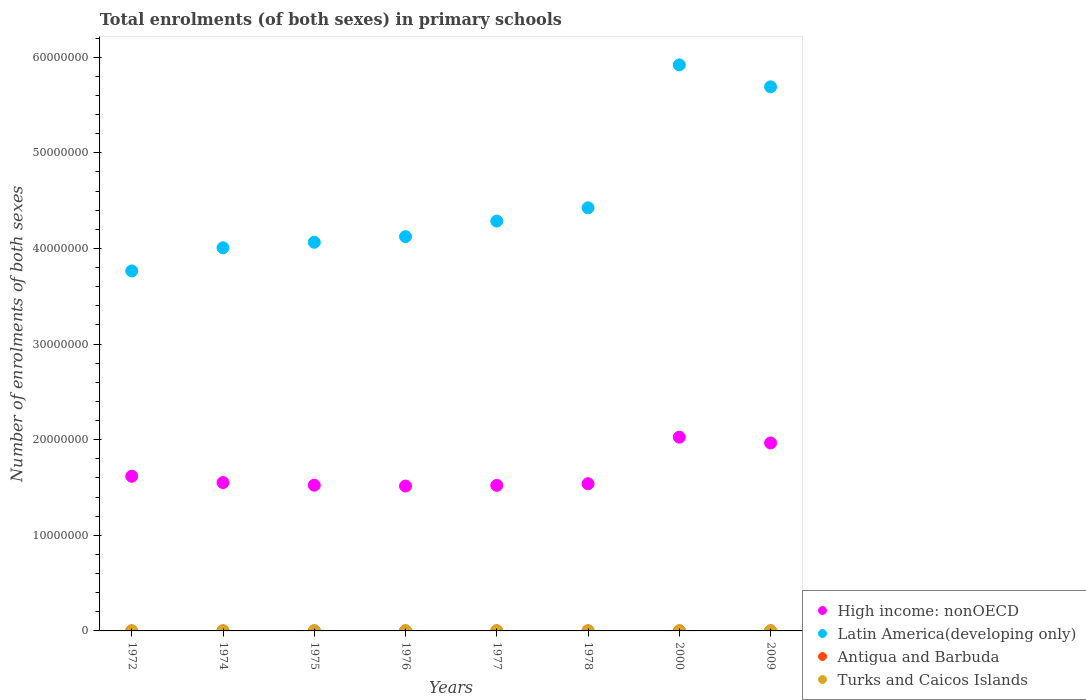How many different coloured dotlines are there?
Ensure brevity in your answer.  4. What is the number of enrolments in primary schools in High income: nonOECD in 1978?
Your answer should be compact. 1.54e+07. Across all years, what is the maximum number of enrolments in primary schools in Latin America(developing only)?
Offer a very short reply. 5.92e+07. Across all years, what is the minimum number of enrolments in primary schools in Turks and Caicos Islands?
Offer a terse response. 1626. In which year was the number of enrolments in primary schools in Turks and Caicos Islands minimum?
Keep it short and to the point. 1975. What is the total number of enrolments in primary schools in Turks and Caicos Islands in the graph?
Give a very brief answer. 1.52e+04. What is the difference between the number of enrolments in primary schools in Antigua and Barbuda in 2000 and that in 2009?
Give a very brief answer. 1749. What is the difference between the number of enrolments in primary schools in Turks and Caicos Islands in 1975 and the number of enrolments in primary schools in High income: nonOECD in 1974?
Your answer should be very brief. -1.55e+07. What is the average number of enrolments in primary schools in Turks and Caicos Islands per year?
Provide a short and direct response. 1906.25. In the year 2000, what is the difference between the number of enrolments in primary schools in Antigua and Barbuda and number of enrolments in primary schools in High income: nonOECD?
Make the answer very short. -2.03e+07. What is the ratio of the number of enrolments in primary schools in Turks and Caicos Islands in 1976 to that in 2009?
Provide a succinct answer. 0.61. Is the number of enrolments in primary schools in Antigua and Barbuda in 1976 less than that in 1978?
Ensure brevity in your answer.  No. Is the difference between the number of enrolments in primary schools in Antigua and Barbuda in 1972 and 1974 greater than the difference between the number of enrolments in primary schools in High income: nonOECD in 1972 and 1974?
Provide a succinct answer. No. What is the difference between the highest and the second highest number of enrolments in primary schools in Latin America(developing only)?
Make the answer very short. 2.30e+06. What is the difference between the highest and the lowest number of enrolments in primary schools in High income: nonOECD?
Your answer should be compact. 5.11e+06. In how many years, is the number of enrolments in primary schools in Latin America(developing only) greater than the average number of enrolments in primary schools in Latin America(developing only) taken over all years?
Ensure brevity in your answer.  2. Is it the case that in every year, the sum of the number of enrolments in primary schools in Antigua and Barbuda and number of enrolments in primary schools in Turks and Caicos Islands  is greater than the sum of number of enrolments in primary schools in High income: nonOECD and number of enrolments in primary schools in Latin America(developing only)?
Give a very brief answer. No. Does the number of enrolments in primary schools in Turks and Caicos Islands monotonically increase over the years?
Offer a very short reply. No. Is the number of enrolments in primary schools in Latin America(developing only) strictly greater than the number of enrolments in primary schools in High income: nonOECD over the years?
Your answer should be very brief. Yes. Is the number of enrolments in primary schools in Latin America(developing only) strictly less than the number of enrolments in primary schools in Turks and Caicos Islands over the years?
Make the answer very short. No. How many years are there in the graph?
Your response must be concise. 8. Are the values on the major ticks of Y-axis written in scientific E-notation?
Provide a short and direct response. No. Does the graph contain any zero values?
Make the answer very short. No. Does the graph contain grids?
Provide a succinct answer. No. How many legend labels are there?
Your answer should be compact. 4. What is the title of the graph?
Give a very brief answer. Total enrolments (of both sexes) in primary schools. Does "Tuvalu" appear as one of the legend labels in the graph?
Offer a terse response. No. What is the label or title of the X-axis?
Your answer should be compact. Years. What is the label or title of the Y-axis?
Offer a terse response. Number of enrolments of both sexes. What is the Number of enrolments of both sexes in High income: nonOECD in 1972?
Offer a terse response. 1.62e+07. What is the Number of enrolments of both sexes in Latin America(developing only) in 1972?
Your answer should be very brief. 3.76e+07. What is the Number of enrolments of both sexes in Antigua and Barbuda in 1972?
Ensure brevity in your answer.  1.19e+04. What is the Number of enrolments of both sexes of Turks and Caicos Islands in 1972?
Ensure brevity in your answer.  1791. What is the Number of enrolments of both sexes of High income: nonOECD in 1974?
Give a very brief answer. 1.55e+07. What is the Number of enrolments of both sexes in Latin America(developing only) in 1974?
Keep it short and to the point. 4.01e+07. What is the Number of enrolments of both sexes of Antigua and Barbuda in 1974?
Keep it short and to the point. 1.12e+04. What is the Number of enrolments of both sexes of Turks and Caicos Islands in 1974?
Keep it short and to the point. 1668. What is the Number of enrolments of both sexes in High income: nonOECD in 1975?
Make the answer very short. 1.52e+07. What is the Number of enrolments of both sexes of Latin America(developing only) in 1975?
Give a very brief answer. 4.06e+07. What is the Number of enrolments of both sexes of Antigua and Barbuda in 1975?
Make the answer very short. 1.09e+04. What is the Number of enrolments of both sexes in Turks and Caicos Islands in 1975?
Your answer should be compact. 1626. What is the Number of enrolments of both sexes in High income: nonOECD in 1976?
Your response must be concise. 1.52e+07. What is the Number of enrolments of both sexes of Latin America(developing only) in 1976?
Provide a short and direct response. 4.12e+07. What is the Number of enrolments of both sexes of Antigua and Barbuda in 1976?
Your answer should be very brief. 1.13e+04. What is the Number of enrolments of both sexes of Turks and Caicos Islands in 1976?
Offer a terse response. 1764. What is the Number of enrolments of both sexes in High income: nonOECD in 1977?
Offer a terse response. 1.52e+07. What is the Number of enrolments of both sexes in Latin America(developing only) in 1977?
Keep it short and to the point. 4.29e+07. What is the Number of enrolments of both sexes in Antigua and Barbuda in 1977?
Your answer should be very brief. 1.09e+04. What is the Number of enrolments of both sexes of Turks and Caicos Islands in 1977?
Offer a very short reply. 1800. What is the Number of enrolments of both sexes in High income: nonOECD in 1978?
Offer a terse response. 1.54e+07. What is the Number of enrolments of both sexes in Latin America(developing only) in 1978?
Provide a short and direct response. 4.43e+07. What is the Number of enrolments of both sexes in Antigua and Barbuda in 1978?
Keep it short and to the point. 1.02e+04. What is the Number of enrolments of both sexes in Turks and Caicos Islands in 1978?
Offer a terse response. 1692. What is the Number of enrolments of both sexes in High income: nonOECD in 2000?
Give a very brief answer. 2.03e+07. What is the Number of enrolments of both sexes in Latin America(developing only) in 2000?
Make the answer very short. 5.92e+07. What is the Number of enrolments of both sexes in Antigua and Barbuda in 2000?
Your response must be concise. 1.30e+04. What is the Number of enrolments of both sexes in Turks and Caicos Islands in 2000?
Provide a succinct answer. 2018. What is the Number of enrolments of both sexes of High income: nonOECD in 2009?
Provide a short and direct response. 1.97e+07. What is the Number of enrolments of both sexes in Latin America(developing only) in 2009?
Give a very brief answer. 5.69e+07. What is the Number of enrolments of both sexes in Antigua and Barbuda in 2009?
Your answer should be compact. 1.13e+04. What is the Number of enrolments of both sexes in Turks and Caicos Islands in 2009?
Offer a very short reply. 2891. Across all years, what is the maximum Number of enrolments of both sexes of High income: nonOECD?
Your response must be concise. 2.03e+07. Across all years, what is the maximum Number of enrolments of both sexes of Latin America(developing only)?
Offer a very short reply. 5.92e+07. Across all years, what is the maximum Number of enrolments of both sexes of Antigua and Barbuda?
Provide a succinct answer. 1.30e+04. Across all years, what is the maximum Number of enrolments of both sexes of Turks and Caicos Islands?
Your answer should be compact. 2891. Across all years, what is the minimum Number of enrolments of both sexes in High income: nonOECD?
Provide a short and direct response. 1.52e+07. Across all years, what is the minimum Number of enrolments of both sexes in Latin America(developing only)?
Your response must be concise. 3.76e+07. Across all years, what is the minimum Number of enrolments of both sexes in Antigua and Barbuda?
Ensure brevity in your answer.  1.02e+04. Across all years, what is the minimum Number of enrolments of both sexes in Turks and Caicos Islands?
Keep it short and to the point. 1626. What is the total Number of enrolments of both sexes in High income: nonOECD in the graph?
Your response must be concise. 1.33e+08. What is the total Number of enrolments of both sexes in Latin America(developing only) in the graph?
Keep it short and to the point. 3.63e+08. What is the total Number of enrolments of both sexes in Antigua and Barbuda in the graph?
Keep it short and to the point. 9.07e+04. What is the total Number of enrolments of both sexes of Turks and Caicos Islands in the graph?
Provide a succinct answer. 1.52e+04. What is the difference between the Number of enrolments of both sexes in High income: nonOECD in 1972 and that in 1974?
Provide a short and direct response. 6.58e+05. What is the difference between the Number of enrolments of both sexes of Latin America(developing only) in 1972 and that in 1974?
Provide a short and direct response. -2.42e+06. What is the difference between the Number of enrolments of both sexes in Antigua and Barbuda in 1972 and that in 1974?
Offer a very short reply. 636. What is the difference between the Number of enrolments of both sexes in Turks and Caicos Islands in 1972 and that in 1974?
Give a very brief answer. 123. What is the difference between the Number of enrolments of both sexes in High income: nonOECD in 1972 and that in 1975?
Provide a short and direct response. 9.34e+05. What is the difference between the Number of enrolments of both sexes of Latin America(developing only) in 1972 and that in 1975?
Your answer should be very brief. -3.00e+06. What is the difference between the Number of enrolments of both sexes in Antigua and Barbuda in 1972 and that in 1975?
Keep it short and to the point. 913. What is the difference between the Number of enrolments of both sexes of Turks and Caicos Islands in 1972 and that in 1975?
Your answer should be compact. 165. What is the difference between the Number of enrolments of both sexes of High income: nonOECD in 1972 and that in 1976?
Offer a terse response. 1.02e+06. What is the difference between the Number of enrolments of both sexes of Latin America(developing only) in 1972 and that in 1976?
Keep it short and to the point. -3.59e+06. What is the difference between the Number of enrolments of both sexes of Antigua and Barbuda in 1972 and that in 1976?
Your answer should be compact. 512. What is the difference between the Number of enrolments of both sexes of Turks and Caicos Islands in 1972 and that in 1976?
Give a very brief answer. 27. What is the difference between the Number of enrolments of both sexes in High income: nonOECD in 1972 and that in 1977?
Make the answer very short. 9.52e+05. What is the difference between the Number of enrolments of both sexes of Latin America(developing only) in 1972 and that in 1977?
Give a very brief answer. -5.21e+06. What is the difference between the Number of enrolments of both sexes in Antigua and Barbuda in 1972 and that in 1977?
Your response must be concise. 940. What is the difference between the Number of enrolments of both sexes in High income: nonOECD in 1972 and that in 1978?
Keep it short and to the point. 7.78e+05. What is the difference between the Number of enrolments of both sexes of Latin America(developing only) in 1972 and that in 1978?
Give a very brief answer. -6.60e+06. What is the difference between the Number of enrolments of both sexes in Antigua and Barbuda in 1972 and that in 1978?
Keep it short and to the point. 1693. What is the difference between the Number of enrolments of both sexes in High income: nonOECD in 1972 and that in 2000?
Your response must be concise. -4.09e+06. What is the difference between the Number of enrolments of both sexes in Latin America(developing only) in 1972 and that in 2000?
Your response must be concise. -2.16e+07. What is the difference between the Number of enrolments of both sexes of Antigua and Barbuda in 1972 and that in 2000?
Offer a terse response. -1173. What is the difference between the Number of enrolments of both sexes of Turks and Caicos Islands in 1972 and that in 2000?
Offer a very short reply. -227. What is the difference between the Number of enrolments of both sexes of High income: nonOECD in 1972 and that in 2009?
Offer a terse response. -3.48e+06. What is the difference between the Number of enrolments of both sexes of Latin America(developing only) in 1972 and that in 2009?
Your response must be concise. -1.93e+07. What is the difference between the Number of enrolments of both sexes of Antigua and Barbuda in 1972 and that in 2009?
Offer a very short reply. 576. What is the difference between the Number of enrolments of both sexes of Turks and Caicos Islands in 1972 and that in 2009?
Offer a terse response. -1100. What is the difference between the Number of enrolments of both sexes in High income: nonOECD in 1974 and that in 1975?
Provide a succinct answer. 2.76e+05. What is the difference between the Number of enrolments of both sexes of Latin America(developing only) in 1974 and that in 1975?
Keep it short and to the point. -5.80e+05. What is the difference between the Number of enrolments of both sexes in Antigua and Barbuda in 1974 and that in 1975?
Your answer should be compact. 277. What is the difference between the Number of enrolments of both sexes in High income: nonOECD in 1974 and that in 1976?
Your answer should be very brief. 3.65e+05. What is the difference between the Number of enrolments of both sexes in Latin America(developing only) in 1974 and that in 1976?
Ensure brevity in your answer.  -1.17e+06. What is the difference between the Number of enrolments of both sexes in Antigua and Barbuda in 1974 and that in 1976?
Make the answer very short. -124. What is the difference between the Number of enrolments of both sexes in Turks and Caicos Islands in 1974 and that in 1976?
Provide a short and direct response. -96. What is the difference between the Number of enrolments of both sexes of High income: nonOECD in 1974 and that in 1977?
Your answer should be compact. 2.95e+05. What is the difference between the Number of enrolments of both sexes of Latin America(developing only) in 1974 and that in 1977?
Provide a succinct answer. -2.79e+06. What is the difference between the Number of enrolments of both sexes in Antigua and Barbuda in 1974 and that in 1977?
Offer a very short reply. 304. What is the difference between the Number of enrolments of both sexes in Turks and Caicos Islands in 1974 and that in 1977?
Provide a short and direct response. -132. What is the difference between the Number of enrolments of both sexes of High income: nonOECD in 1974 and that in 1978?
Make the answer very short. 1.20e+05. What is the difference between the Number of enrolments of both sexes in Latin America(developing only) in 1974 and that in 1978?
Your response must be concise. -4.18e+06. What is the difference between the Number of enrolments of both sexes of Antigua and Barbuda in 1974 and that in 1978?
Offer a very short reply. 1057. What is the difference between the Number of enrolments of both sexes of Turks and Caicos Islands in 1974 and that in 1978?
Offer a very short reply. -24. What is the difference between the Number of enrolments of both sexes of High income: nonOECD in 1974 and that in 2000?
Your answer should be compact. -4.75e+06. What is the difference between the Number of enrolments of both sexes of Latin America(developing only) in 1974 and that in 2000?
Provide a succinct answer. -1.91e+07. What is the difference between the Number of enrolments of both sexes in Antigua and Barbuda in 1974 and that in 2000?
Offer a very short reply. -1809. What is the difference between the Number of enrolments of both sexes of Turks and Caicos Islands in 1974 and that in 2000?
Provide a succinct answer. -350. What is the difference between the Number of enrolments of both sexes in High income: nonOECD in 1974 and that in 2009?
Your answer should be compact. -4.14e+06. What is the difference between the Number of enrolments of both sexes in Latin America(developing only) in 1974 and that in 2009?
Make the answer very short. -1.68e+07. What is the difference between the Number of enrolments of both sexes in Antigua and Barbuda in 1974 and that in 2009?
Offer a terse response. -60. What is the difference between the Number of enrolments of both sexes in Turks and Caicos Islands in 1974 and that in 2009?
Your answer should be very brief. -1223. What is the difference between the Number of enrolments of both sexes in High income: nonOECD in 1975 and that in 1976?
Your answer should be very brief. 8.88e+04. What is the difference between the Number of enrolments of both sexes of Latin America(developing only) in 1975 and that in 1976?
Ensure brevity in your answer.  -5.86e+05. What is the difference between the Number of enrolments of both sexes in Antigua and Barbuda in 1975 and that in 1976?
Provide a short and direct response. -401. What is the difference between the Number of enrolments of both sexes of Turks and Caicos Islands in 1975 and that in 1976?
Provide a short and direct response. -138. What is the difference between the Number of enrolments of both sexes of High income: nonOECD in 1975 and that in 1977?
Your answer should be compact. 1.85e+04. What is the difference between the Number of enrolments of both sexes of Latin America(developing only) in 1975 and that in 1977?
Give a very brief answer. -2.21e+06. What is the difference between the Number of enrolments of both sexes of Antigua and Barbuda in 1975 and that in 1977?
Offer a very short reply. 27. What is the difference between the Number of enrolments of both sexes in Turks and Caicos Islands in 1975 and that in 1977?
Keep it short and to the point. -174. What is the difference between the Number of enrolments of both sexes of High income: nonOECD in 1975 and that in 1978?
Give a very brief answer. -1.56e+05. What is the difference between the Number of enrolments of both sexes in Latin America(developing only) in 1975 and that in 1978?
Your answer should be very brief. -3.60e+06. What is the difference between the Number of enrolments of both sexes in Antigua and Barbuda in 1975 and that in 1978?
Keep it short and to the point. 780. What is the difference between the Number of enrolments of both sexes in Turks and Caicos Islands in 1975 and that in 1978?
Offer a very short reply. -66. What is the difference between the Number of enrolments of both sexes in High income: nonOECD in 1975 and that in 2000?
Your answer should be very brief. -5.03e+06. What is the difference between the Number of enrolments of both sexes in Latin America(developing only) in 1975 and that in 2000?
Provide a short and direct response. -1.86e+07. What is the difference between the Number of enrolments of both sexes of Antigua and Barbuda in 1975 and that in 2000?
Make the answer very short. -2086. What is the difference between the Number of enrolments of both sexes of Turks and Caicos Islands in 1975 and that in 2000?
Offer a very short reply. -392. What is the difference between the Number of enrolments of both sexes of High income: nonOECD in 1975 and that in 2009?
Provide a succinct answer. -4.42e+06. What is the difference between the Number of enrolments of both sexes in Latin America(developing only) in 1975 and that in 2009?
Offer a very short reply. -1.63e+07. What is the difference between the Number of enrolments of both sexes of Antigua and Barbuda in 1975 and that in 2009?
Provide a succinct answer. -337. What is the difference between the Number of enrolments of both sexes of Turks and Caicos Islands in 1975 and that in 2009?
Keep it short and to the point. -1265. What is the difference between the Number of enrolments of both sexes in High income: nonOECD in 1976 and that in 1977?
Make the answer very short. -7.03e+04. What is the difference between the Number of enrolments of both sexes in Latin America(developing only) in 1976 and that in 1977?
Offer a terse response. -1.63e+06. What is the difference between the Number of enrolments of both sexes of Antigua and Barbuda in 1976 and that in 1977?
Your answer should be very brief. 428. What is the difference between the Number of enrolments of both sexes of Turks and Caicos Islands in 1976 and that in 1977?
Offer a very short reply. -36. What is the difference between the Number of enrolments of both sexes in High income: nonOECD in 1976 and that in 1978?
Provide a succinct answer. -2.45e+05. What is the difference between the Number of enrolments of both sexes of Latin America(developing only) in 1976 and that in 1978?
Make the answer very short. -3.02e+06. What is the difference between the Number of enrolments of both sexes in Antigua and Barbuda in 1976 and that in 1978?
Offer a terse response. 1181. What is the difference between the Number of enrolments of both sexes of Turks and Caicos Islands in 1976 and that in 1978?
Offer a terse response. 72. What is the difference between the Number of enrolments of both sexes of High income: nonOECD in 1976 and that in 2000?
Give a very brief answer. -5.11e+06. What is the difference between the Number of enrolments of both sexes of Latin America(developing only) in 1976 and that in 2000?
Give a very brief answer. -1.80e+07. What is the difference between the Number of enrolments of both sexes of Antigua and Barbuda in 1976 and that in 2000?
Provide a short and direct response. -1685. What is the difference between the Number of enrolments of both sexes in Turks and Caicos Islands in 1976 and that in 2000?
Provide a succinct answer. -254. What is the difference between the Number of enrolments of both sexes of High income: nonOECD in 1976 and that in 2009?
Provide a succinct answer. -4.51e+06. What is the difference between the Number of enrolments of both sexes of Latin America(developing only) in 1976 and that in 2009?
Make the answer very short. -1.57e+07. What is the difference between the Number of enrolments of both sexes of Turks and Caicos Islands in 1976 and that in 2009?
Offer a terse response. -1127. What is the difference between the Number of enrolments of both sexes of High income: nonOECD in 1977 and that in 1978?
Your answer should be compact. -1.75e+05. What is the difference between the Number of enrolments of both sexes in Latin America(developing only) in 1977 and that in 1978?
Offer a terse response. -1.39e+06. What is the difference between the Number of enrolments of both sexes in Antigua and Barbuda in 1977 and that in 1978?
Offer a terse response. 753. What is the difference between the Number of enrolments of both sexes of Turks and Caicos Islands in 1977 and that in 1978?
Make the answer very short. 108. What is the difference between the Number of enrolments of both sexes of High income: nonOECD in 1977 and that in 2000?
Your answer should be compact. -5.04e+06. What is the difference between the Number of enrolments of both sexes in Latin America(developing only) in 1977 and that in 2000?
Offer a very short reply. -1.63e+07. What is the difference between the Number of enrolments of both sexes in Antigua and Barbuda in 1977 and that in 2000?
Offer a very short reply. -2113. What is the difference between the Number of enrolments of both sexes of Turks and Caicos Islands in 1977 and that in 2000?
Offer a terse response. -218. What is the difference between the Number of enrolments of both sexes in High income: nonOECD in 1977 and that in 2009?
Keep it short and to the point. -4.44e+06. What is the difference between the Number of enrolments of both sexes of Latin America(developing only) in 1977 and that in 2009?
Keep it short and to the point. -1.40e+07. What is the difference between the Number of enrolments of both sexes in Antigua and Barbuda in 1977 and that in 2009?
Your answer should be very brief. -364. What is the difference between the Number of enrolments of both sexes of Turks and Caicos Islands in 1977 and that in 2009?
Your response must be concise. -1091. What is the difference between the Number of enrolments of both sexes in High income: nonOECD in 1978 and that in 2000?
Make the answer very short. -4.87e+06. What is the difference between the Number of enrolments of both sexes of Latin America(developing only) in 1978 and that in 2000?
Your response must be concise. -1.49e+07. What is the difference between the Number of enrolments of both sexes in Antigua and Barbuda in 1978 and that in 2000?
Offer a terse response. -2866. What is the difference between the Number of enrolments of both sexes in Turks and Caicos Islands in 1978 and that in 2000?
Provide a short and direct response. -326. What is the difference between the Number of enrolments of both sexes of High income: nonOECD in 1978 and that in 2009?
Offer a very short reply. -4.26e+06. What is the difference between the Number of enrolments of both sexes in Latin America(developing only) in 1978 and that in 2009?
Give a very brief answer. -1.27e+07. What is the difference between the Number of enrolments of both sexes in Antigua and Barbuda in 1978 and that in 2009?
Ensure brevity in your answer.  -1117. What is the difference between the Number of enrolments of both sexes of Turks and Caicos Islands in 1978 and that in 2009?
Keep it short and to the point. -1199. What is the difference between the Number of enrolments of both sexes in High income: nonOECD in 2000 and that in 2009?
Provide a succinct answer. 6.07e+05. What is the difference between the Number of enrolments of both sexes in Latin America(developing only) in 2000 and that in 2009?
Provide a short and direct response. 2.30e+06. What is the difference between the Number of enrolments of both sexes of Antigua and Barbuda in 2000 and that in 2009?
Make the answer very short. 1749. What is the difference between the Number of enrolments of both sexes of Turks and Caicos Islands in 2000 and that in 2009?
Provide a short and direct response. -873. What is the difference between the Number of enrolments of both sexes of High income: nonOECD in 1972 and the Number of enrolments of both sexes of Latin America(developing only) in 1974?
Provide a short and direct response. -2.39e+07. What is the difference between the Number of enrolments of both sexes of High income: nonOECD in 1972 and the Number of enrolments of both sexes of Antigua and Barbuda in 1974?
Ensure brevity in your answer.  1.62e+07. What is the difference between the Number of enrolments of both sexes in High income: nonOECD in 1972 and the Number of enrolments of both sexes in Turks and Caicos Islands in 1974?
Your response must be concise. 1.62e+07. What is the difference between the Number of enrolments of both sexes in Latin America(developing only) in 1972 and the Number of enrolments of both sexes in Antigua and Barbuda in 1974?
Offer a very short reply. 3.76e+07. What is the difference between the Number of enrolments of both sexes in Latin America(developing only) in 1972 and the Number of enrolments of both sexes in Turks and Caicos Islands in 1974?
Offer a terse response. 3.76e+07. What is the difference between the Number of enrolments of both sexes of Antigua and Barbuda in 1972 and the Number of enrolments of both sexes of Turks and Caicos Islands in 1974?
Provide a succinct answer. 1.02e+04. What is the difference between the Number of enrolments of both sexes of High income: nonOECD in 1972 and the Number of enrolments of both sexes of Latin America(developing only) in 1975?
Provide a short and direct response. -2.45e+07. What is the difference between the Number of enrolments of both sexes in High income: nonOECD in 1972 and the Number of enrolments of both sexes in Antigua and Barbuda in 1975?
Offer a very short reply. 1.62e+07. What is the difference between the Number of enrolments of both sexes of High income: nonOECD in 1972 and the Number of enrolments of both sexes of Turks and Caicos Islands in 1975?
Give a very brief answer. 1.62e+07. What is the difference between the Number of enrolments of both sexes in Latin America(developing only) in 1972 and the Number of enrolments of both sexes in Antigua and Barbuda in 1975?
Give a very brief answer. 3.76e+07. What is the difference between the Number of enrolments of both sexes of Latin America(developing only) in 1972 and the Number of enrolments of both sexes of Turks and Caicos Islands in 1975?
Your answer should be very brief. 3.76e+07. What is the difference between the Number of enrolments of both sexes in Antigua and Barbuda in 1972 and the Number of enrolments of both sexes in Turks and Caicos Islands in 1975?
Your response must be concise. 1.02e+04. What is the difference between the Number of enrolments of both sexes of High income: nonOECD in 1972 and the Number of enrolments of both sexes of Latin America(developing only) in 1976?
Your answer should be very brief. -2.51e+07. What is the difference between the Number of enrolments of both sexes of High income: nonOECD in 1972 and the Number of enrolments of both sexes of Antigua and Barbuda in 1976?
Give a very brief answer. 1.62e+07. What is the difference between the Number of enrolments of both sexes in High income: nonOECD in 1972 and the Number of enrolments of both sexes in Turks and Caicos Islands in 1976?
Your answer should be compact. 1.62e+07. What is the difference between the Number of enrolments of both sexes of Latin America(developing only) in 1972 and the Number of enrolments of both sexes of Antigua and Barbuda in 1976?
Make the answer very short. 3.76e+07. What is the difference between the Number of enrolments of both sexes in Latin America(developing only) in 1972 and the Number of enrolments of both sexes in Turks and Caicos Islands in 1976?
Provide a short and direct response. 3.76e+07. What is the difference between the Number of enrolments of both sexes of Antigua and Barbuda in 1972 and the Number of enrolments of both sexes of Turks and Caicos Islands in 1976?
Provide a succinct answer. 1.01e+04. What is the difference between the Number of enrolments of both sexes of High income: nonOECD in 1972 and the Number of enrolments of both sexes of Latin America(developing only) in 1977?
Your response must be concise. -2.67e+07. What is the difference between the Number of enrolments of both sexes in High income: nonOECD in 1972 and the Number of enrolments of both sexes in Antigua and Barbuda in 1977?
Keep it short and to the point. 1.62e+07. What is the difference between the Number of enrolments of both sexes of High income: nonOECD in 1972 and the Number of enrolments of both sexes of Turks and Caicos Islands in 1977?
Your response must be concise. 1.62e+07. What is the difference between the Number of enrolments of both sexes in Latin America(developing only) in 1972 and the Number of enrolments of both sexes in Antigua and Barbuda in 1977?
Make the answer very short. 3.76e+07. What is the difference between the Number of enrolments of both sexes of Latin America(developing only) in 1972 and the Number of enrolments of both sexes of Turks and Caicos Islands in 1977?
Provide a short and direct response. 3.76e+07. What is the difference between the Number of enrolments of both sexes of Antigua and Barbuda in 1972 and the Number of enrolments of both sexes of Turks and Caicos Islands in 1977?
Your answer should be very brief. 1.01e+04. What is the difference between the Number of enrolments of both sexes of High income: nonOECD in 1972 and the Number of enrolments of both sexes of Latin America(developing only) in 1978?
Offer a terse response. -2.81e+07. What is the difference between the Number of enrolments of both sexes in High income: nonOECD in 1972 and the Number of enrolments of both sexes in Antigua and Barbuda in 1978?
Your response must be concise. 1.62e+07. What is the difference between the Number of enrolments of both sexes in High income: nonOECD in 1972 and the Number of enrolments of both sexes in Turks and Caicos Islands in 1978?
Your response must be concise. 1.62e+07. What is the difference between the Number of enrolments of both sexes in Latin America(developing only) in 1972 and the Number of enrolments of both sexes in Antigua and Barbuda in 1978?
Your answer should be compact. 3.76e+07. What is the difference between the Number of enrolments of both sexes of Latin America(developing only) in 1972 and the Number of enrolments of both sexes of Turks and Caicos Islands in 1978?
Give a very brief answer. 3.76e+07. What is the difference between the Number of enrolments of both sexes of Antigua and Barbuda in 1972 and the Number of enrolments of both sexes of Turks and Caicos Islands in 1978?
Your response must be concise. 1.02e+04. What is the difference between the Number of enrolments of both sexes in High income: nonOECD in 1972 and the Number of enrolments of both sexes in Latin America(developing only) in 2000?
Provide a short and direct response. -4.30e+07. What is the difference between the Number of enrolments of both sexes in High income: nonOECD in 1972 and the Number of enrolments of both sexes in Antigua and Barbuda in 2000?
Offer a very short reply. 1.62e+07. What is the difference between the Number of enrolments of both sexes in High income: nonOECD in 1972 and the Number of enrolments of both sexes in Turks and Caicos Islands in 2000?
Provide a short and direct response. 1.62e+07. What is the difference between the Number of enrolments of both sexes of Latin America(developing only) in 1972 and the Number of enrolments of both sexes of Antigua and Barbuda in 2000?
Your answer should be compact. 3.76e+07. What is the difference between the Number of enrolments of both sexes in Latin America(developing only) in 1972 and the Number of enrolments of both sexes in Turks and Caicos Islands in 2000?
Your answer should be very brief. 3.76e+07. What is the difference between the Number of enrolments of both sexes in Antigua and Barbuda in 1972 and the Number of enrolments of both sexes in Turks and Caicos Islands in 2000?
Provide a short and direct response. 9834. What is the difference between the Number of enrolments of both sexes of High income: nonOECD in 1972 and the Number of enrolments of both sexes of Latin America(developing only) in 2009?
Your answer should be very brief. -4.07e+07. What is the difference between the Number of enrolments of both sexes of High income: nonOECD in 1972 and the Number of enrolments of both sexes of Antigua and Barbuda in 2009?
Give a very brief answer. 1.62e+07. What is the difference between the Number of enrolments of both sexes in High income: nonOECD in 1972 and the Number of enrolments of both sexes in Turks and Caicos Islands in 2009?
Provide a succinct answer. 1.62e+07. What is the difference between the Number of enrolments of both sexes of Latin America(developing only) in 1972 and the Number of enrolments of both sexes of Antigua and Barbuda in 2009?
Provide a succinct answer. 3.76e+07. What is the difference between the Number of enrolments of both sexes of Latin America(developing only) in 1972 and the Number of enrolments of both sexes of Turks and Caicos Islands in 2009?
Provide a short and direct response. 3.76e+07. What is the difference between the Number of enrolments of both sexes of Antigua and Barbuda in 1972 and the Number of enrolments of both sexes of Turks and Caicos Islands in 2009?
Provide a short and direct response. 8961. What is the difference between the Number of enrolments of both sexes in High income: nonOECD in 1974 and the Number of enrolments of both sexes in Latin America(developing only) in 1975?
Keep it short and to the point. -2.51e+07. What is the difference between the Number of enrolments of both sexes of High income: nonOECD in 1974 and the Number of enrolments of both sexes of Antigua and Barbuda in 1975?
Offer a very short reply. 1.55e+07. What is the difference between the Number of enrolments of both sexes in High income: nonOECD in 1974 and the Number of enrolments of both sexes in Turks and Caicos Islands in 1975?
Keep it short and to the point. 1.55e+07. What is the difference between the Number of enrolments of both sexes of Latin America(developing only) in 1974 and the Number of enrolments of both sexes of Antigua and Barbuda in 1975?
Your answer should be very brief. 4.01e+07. What is the difference between the Number of enrolments of both sexes in Latin America(developing only) in 1974 and the Number of enrolments of both sexes in Turks and Caicos Islands in 1975?
Provide a succinct answer. 4.01e+07. What is the difference between the Number of enrolments of both sexes of Antigua and Barbuda in 1974 and the Number of enrolments of both sexes of Turks and Caicos Islands in 1975?
Ensure brevity in your answer.  9590. What is the difference between the Number of enrolments of both sexes of High income: nonOECD in 1974 and the Number of enrolments of both sexes of Latin America(developing only) in 1976?
Provide a succinct answer. -2.57e+07. What is the difference between the Number of enrolments of both sexes in High income: nonOECD in 1974 and the Number of enrolments of both sexes in Antigua and Barbuda in 1976?
Ensure brevity in your answer.  1.55e+07. What is the difference between the Number of enrolments of both sexes in High income: nonOECD in 1974 and the Number of enrolments of both sexes in Turks and Caicos Islands in 1976?
Offer a very short reply. 1.55e+07. What is the difference between the Number of enrolments of both sexes of Latin America(developing only) in 1974 and the Number of enrolments of both sexes of Antigua and Barbuda in 1976?
Keep it short and to the point. 4.01e+07. What is the difference between the Number of enrolments of both sexes of Latin America(developing only) in 1974 and the Number of enrolments of both sexes of Turks and Caicos Islands in 1976?
Your answer should be compact. 4.01e+07. What is the difference between the Number of enrolments of both sexes of Antigua and Barbuda in 1974 and the Number of enrolments of both sexes of Turks and Caicos Islands in 1976?
Your response must be concise. 9452. What is the difference between the Number of enrolments of both sexes of High income: nonOECD in 1974 and the Number of enrolments of both sexes of Latin America(developing only) in 1977?
Your answer should be very brief. -2.73e+07. What is the difference between the Number of enrolments of both sexes of High income: nonOECD in 1974 and the Number of enrolments of both sexes of Antigua and Barbuda in 1977?
Offer a very short reply. 1.55e+07. What is the difference between the Number of enrolments of both sexes in High income: nonOECD in 1974 and the Number of enrolments of both sexes in Turks and Caicos Islands in 1977?
Provide a succinct answer. 1.55e+07. What is the difference between the Number of enrolments of both sexes in Latin America(developing only) in 1974 and the Number of enrolments of both sexes in Antigua and Barbuda in 1977?
Your answer should be compact. 4.01e+07. What is the difference between the Number of enrolments of both sexes of Latin America(developing only) in 1974 and the Number of enrolments of both sexes of Turks and Caicos Islands in 1977?
Make the answer very short. 4.01e+07. What is the difference between the Number of enrolments of both sexes of Antigua and Barbuda in 1974 and the Number of enrolments of both sexes of Turks and Caicos Islands in 1977?
Provide a succinct answer. 9416. What is the difference between the Number of enrolments of both sexes in High income: nonOECD in 1974 and the Number of enrolments of both sexes in Latin America(developing only) in 1978?
Ensure brevity in your answer.  -2.87e+07. What is the difference between the Number of enrolments of both sexes in High income: nonOECD in 1974 and the Number of enrolments of both sexes in Antigua and Barbuda in 1978?
Your answer should be very brief. 1.55e+07. What is the difference between the Number of enrolments of both sexes of High income: nonOECD in 1974 and the Number of enrolments of both sexes of Turks and Caicos Islands in 1978?
Give a very brief answer. 1.55e+07. What is the difference between the Number of enrolments of both sexes in Latin America(developing only) in 1974 and the Number of enrolments of both sexes in Antigua and Barbuda in 1978?
Your answer should be compact. 4.01e+07. What is the difference between the Number of enrolments of both sexes in Latin America(developing only) in 1974 and the Number of enrolments of both sexes in Turks and Caicos Islands in 1978?
Your response must be concise. 4.01e+07. What is the difference between the Number of enrolments of both sexes in Antigua and Barbuda in 1974 and the Number of enrolments of both sexes in Turks and Caicos Islands in 1978?
Provide a succinct answer. 9524. What is the difference between the Number of enrolments of both sexes in High income: nonOECD in 1974 and the Number of enrolments of both sexes in Latin America(developing only) in 2000?
Provide a short and direct response. -4.37e+07. What is the difference between the Number of enrolments of both sexes in High income: nonOECD in 1974 and the Number of enrolments of both sexes in Antigua and Barbuda in 2000?
Offer a very short reply. 1.55e+07. What is the difference between the Number of enrolments of both sexes of High income: nonOECD in 1974 and the Number of enrolments of both sexes of Turks and Caicos Islands in 2000?
Provide a succinct answer. 1.55e+07. What is the difference between the Number of enrolments of both sexes in Latin America(developing only) in 1974 and the Number of enrolments of both sexes in Antigua and Barbuda in 2000?
Make the answer very short. 4.01e+07. What is the difference between the Number of enrolments of both sexes in Latin America(developing only) in 1974 and the Number of enrolments of both sexes in Turks and Caicos Islands in 2000?
Offer a terse response. 4.01e+07. What is the difference between the Number of enrolments of both sexes in Antigua and Barbuda in 1974 and the Number of enrolments of both sexes in Turks and Caicos Islands in 2000?
Provide a succinct answer. 9198. What is the difference between the Number of enrolments of both sexes of High income: nonOECD in 1974 and the Number of enrolments of both sexes of Latin America(developing only) in 2009?
Your response must be concise. -4.14e+07. What is the difference between the Number of enrolments of both sexes of High income: nonOECD in 1974 and the Number of enrolments of both sexes of Antigua and Barbuda in 2009?
Provide a short and direct response. 1.55e+07. What is the difference between the Number of enrolments of both sexes in High income: nonOECD in 1974 and the Number of enrolments of both sexes in Turks and Caicos Islands in 2009?
Offer a very short reply. 1.55e+07. What is the difference between the Number of enrolments of both sexes in Latin America(developing only) in 1974 and the Number of enrolments of both sexes in Antigua and Barbuda in 2009?
Offer a very short reply. 4.01e+07. What is the difference between the Number of enrolments of both sexes in Latin America(developing only) in 1974 and the Number of enrolments of both sexes in Turks and Caicos Islands in 2009?
Ensure brevity in your answer.  4.01e+07. What is the difference between the Number of enrolments of both sexes of Antigua and Barbuda in 1974 and the Number of enrolments of both sexes of Turks and Caicos Islands in 2009?
Your response must be concise. 8325. What is the difference between the Number of enrolments of both sexes in High income: nonOECD in 1975 and the Number of enrolments of both sexes in Latin America(developing only) in 1976?
Provide a short and direct response. -2.60e+07. What is the difference between the Number of enrolments of both sexes in High income: nonOECD in 1975 and the Number of enrolments of both sexes in Antigua and Barbuda in 1976?
Your answer should be compact. 1.52e+07. What is the difference between the Number of enrolments of both sexes in High income: nonOECD in 1975 and the Number of enrolments of both sexes in Turks and Caicos Islands in 1976?
Keep it short and to the point. 1.52e+07. What is the difference between the Number of enrolments of both sexes of Latin America(developing only) in 1975 and the Number of enrolments of both sexes of Antigua and Barbuda in 1976?
Your answer should be very brief. 4.06e+07. What is the difference between the Number of enrolments of both sexes of Latin America(developing only) in 1975 and the Number of enrolments of both sexes of Turks and Caicos Islands in 1976?
Provide a succinct answer. 4.06e+07. What is the difference between the Number of enrolments of both sexes of Antigua and Barbuda in 1975 and the Number of enrolments of both sexes of Turks and Caicos Islands in 1976?
Your response must be concise. 9175. What is the difference between the Number of enrolments of both sexes in High income: nonOECD in 1975 and the Number of enrolments of both sexes in Latin America(developing only) in 1977?
Offer a very short reply. -2.76e+07. What is the difference between the Number of enrolments of both sexes of High income: nonOECD in 1975 and the Number of enrolments of both sexes of Antigua and Barbuda in 1977?
Give a very brief answer. 1.52e+07. What is the difference between the Number of enrolments of both sexes in High income: nonOECD in 1975 and the Number of enrolments of both sexes in Turks and Caicos Islands in 1977?
Provide a short and direct response. 1.52e+07. What is the difference between the Number of enrolments of both sexes of Latin America(developing only) in 1975 and the Number of enrolments of both sexes of Antigua and Barbuda in 1977?
Provide a short and direct response. 4.06e+07. What is the difference between the Number of enrolments of both sexes in Latin America(developing only) in 1975 and the Number of enrolments of both sexes in Turks and Caicos Islands in 1977?
Your response must be concise. 4.06e+07. What is the difference between the Number of enrolments of both sexes of Antigua and Barbuda in 1975 and the Number of enrolments of both sexes of Turks and Caicos Islands in 1977?
Offer a very short reply. 9139. What is the difference between the Number of enrolments of both sexes in High income: nonOECD in 1975 and the Number of enrolments of both sexes in Latin America(developing only) in 1978?
Your response must be concise. -2.90e+07. What is the difference between the Number of enrolments of both sexes of High income: nonOECD in 1975 and the Number of enrolments of both sexes of Antigua and Barbuda in 1978?
Your response must be concise. 1.52e+07. What is the difference between the Number of enrolments of both sexes of High income: nonOECD in 1975 and the Number of enrolments of both sexes of Turks and Caicos Islands in 1978?
Your response must be concise. 1.52e+07. What is the difference between the Number of enrolments of both sexes in Latin America(developing only) in 1975 and the Number of enrolments of both sexes in Antigua and Barbuda in 1978?
Your response must be concise. 4.06e+07. What is the difference between the Number of enrolments of both sexes in Latin America(developing only) in 1975 and the Number of enrolments of both sexes in Turks and Caicos Islands in 1978?
Your answer should be compact. 4.06e+07. What is the difference between the Number of enrolments of both sexes in Antigua and Barbuda in 1975 and the Number of enrolments of both sexes in Turks and Caicos Islands in 1978?
Offer a very short reply. 9247. What is the difference between the Number of enrolments of both sexes in High income: nonOECD in 1975 and the Number of enrolments of both sexes in Latin America(developing only) in 2000?
Your answer should be compact. -4.40e+07. What is the difference between the Number of enrolments of both sexes in High income: nonOECD in 1975 and the Number of enrolments of both sexes in Antigua and Barbuda in 2000?
Offer a very short reply. 1.52e+07. What is the difference between the Number of enrolments of both sexes in High income: nonOECD in 1975 and the Number of enrolments of both sexes in Turks and Caicos Islands in 2000?
Your answer should be very brief. 1.52e+07. What is the difference between the Number of enrolments of both sexes of Latin America(developing only) in 1975 and the Number of enrolments of both sexes of Antigua and Barbuda in 2000?
Offer a terse response. 4.06e+07. What is the difference between the Number of enrolments of both sexes of Latin America(developing only) in 1975 and the Number of enrolments of both sexes of Turks and Caicos Islands in 2000?
Your answer should be compact. 4.06e+07. What is the difference between the Number of enrolments of both sexes of Antigua and Barbuda in 1975 and the Number of enrolments of both sexes of Turks and Caicos Islands in 2000?
Ensure brevity in your answer.  8921. What is the difference between the Number of enrolments of both sexes in High income: nonOECD in 1975 and the Number of enrolments of both sexes in Latin America(developing only) in 2009?
Your answer should be compact. -4.17e+07. What is the difference between the Number of enrolments of both sexes of High income: nonOECD in 1975 and the Number of enrolments of both sexes of Antigua and Barbuda in 2009?
Provide a short and direct response. 1.52e+07. What is the difference between the Number of enrolments of both sexes in High income: nonOECD in 1975 and the Number of enrolments of both sexes in Turks and Caicos Islands in 2009?
Offer a very short reply. 1.52e+07. What is the difference between the Number of enrolments of both sexes of Latin America(developing only) in 1975 and the Number of enrolments of both sexes of Antigua and Barbuda in 2009?
Keep it short and to the point. 4.06e+07. What is the difference between the Number of enrolments of both sexes in Latin America(developing only) in 1975 and the Number of enrolments of both sexes in Turks and Caicos Islands in 2009?
Provide a succinct answer. 4.06e+07. What is the difference between the Number of enrolments of both sexes in Antigua and Barbuda in 1975 and the Number of enrolments of both sexes in Turks and Caicos Islands in 2009?
Your answer should be very brief. 8048. What is the difference between the Number of enrolments of both sexes of High income: nonOECD in 1976 and the Number of enrolments of both sexes of Latin America(developing only) in 1977?
Give a very brief answer. -2.77e+07. What is the difference between the Number of enrolments of both sexes in High income: nonOECD in 1976 and the Number of enrolments of both sexes in Antigua and Barbuda in 1977?
Ensure brevity in your answer.  1.51e+07. What is the difference between the Number of enrolments of both sexes in High income: nonOECD in 1976 and the Number of enrolments of both sexes in Turks and Caicos Islands in 1977?
Provide a succinct answer. 1.51e+07. What is the difference between the Number of enrolments of both sexes in Latin America(developing only) in 1976 and the Number of enrolments of both sexes in Antigua and Barbuda in 1977?
Make the answer very short. 4.12e+07. What is the difference between the Number of enrolments of both sexes of Latin America(developing only) in 1976 and the Number of enrolments of both sexes of Turks and Caicos Islands in 1977?
Offer a very short reply. 4.12e+07. What is the difference between the Number of enrolments of both sexes in Antigua and Barbuda in 1976 and the Number of enrolments of both sexes in Turks and Caicos Islands in 1977?
Keep it short and to the point. 9540. What is the difference between the Number of enrolments of both sexes of High income: nonOECD in 1976 and the Number of enrolments of both sexes of Latin America(developing only) in 1978?
Give a very brief answer. -2.91e+07. What is the difference between the Number of enrolments of both sexes of High income: nonOECD in 1976 and the Number of enrolments of both sexes of Antigua and Barbuda in 1978?
Give a very brief answer. 1.51e+07. What is the difference between the Number of enrolments of both sexes in High income: nonOECD in 1976 and the Number of enrolments of both sexes in Turks and Caicos Islands in 1978?
Ensure brevity in your answer.  1.51e+07. What is the difference between the Number of enrolments of both sexes of Latin America(developing only) in 1976 and the Number of enrolments of both sexes of Antigua and Barbuda in 1978?
Your answer should be compact. 4.12e+07. What is the difference between the Number of enrolments of both sexes in Latin America(developing only) in 1976 and the Number of enrolments of both sexes in Turks and Caicos Islands in 1978?
Keep it short and to the point. 4.12e+07. What is the difference between the Number of enrolments of both sexes of Antigua and Barbuda in 1976 and the Number of enrolments of both sexes of Turks and Caicos Islands in 1978?
Ensure brevity in your answer.  9648. What is the difference between the Number of enrolments of both sexes of High income: nonOECD in 1976 and the Number of enrolments of both sexes of Latin America(developing only) in 2000?
Offer a terse response. -4.40e+07. What is the difference between the Number of enrolments of both sexes in High income: nonOECD in 1976 and the Number of enrolments of both sexes in Antigua and Barbuda in 2000?
Offer a very short reply. 1.51e+07. What is the difference between the Number of enrolments of both sexes of High income: nonOECD in 1976 and the Number of enrolments of both sexes of Turks and Caicos Islands in 2000?
Make the answer very short. 1.51e+07. What is the difference between the Number of enrolments of both sexes of Latin America(developing only) in 1976 and the Number of enrolments of both sexes of Antigua and Barbuda in 2000?
Your answer should be very brief. 4.12e+07. What is the difference between the Number of enrolments of both sexes of Latin America(developing only) in 1976 and the Number of enrolments of both sexes of Turks and Caicos Islands in 2000?
Make the answer very short. 4.12e+07. What is the difference between the Number of enrolments of both sexes in Antigua and Barbuda in 1976 and the Number of enrolments of both sexes in Turks and Caicos Islands in 2000?
Offer a very short reply. 9322. What is the difference between the Number of enrolments of both sexes of High income: nonOECD in 1976 and the Number of enrolments of both sexes of Latin America(developing only) in 2009?
Provide a short and direct response. -4.18e+07. What is the difference between the Number of enrolments of both sexes in High income: nonOECD in 1976 and the Number of enrolments of both sexes in Antigua and Barbuda in 2009?
Your response must be concise. 1.51e+07. What is the difference between the Number of enrolments of both sexes of High income: nonOECD in 1976 and the Number of enrolments of both sexes of Turks and Caicos Islands in 2009?
Offer a very short reply. 1.51e+07. What is the difference between the Number of enrolments of both sexes in Latin America(developing only) in 1976 and the Number of enrolments of both sexes in Antigua and Barbuda in 2009?
Provide a short and direct response. 4.12e+07. What is the difference between the Number of enrolments of both sexes in Latin America(developing only) in 1976 and the Number of enrolments of both sexes in Turks and Caicos Islands in 2009?
Provide a short and direct response. 4.12e+07. What is the difference between the Number of enrolments of both sexes in Antigua and Barbuda in 1976 and the Number of enrolments of both sexes in Turks and Caicos Islands in 2009?
Keep it short and to the point. 8449. What is the difference between the Number of enrolments of both sexes of High income: nonOECD in 1977 and the Number of enrolments of both sexes of Latin America(developing only) in 1978?
Offer a terse response. -2.90e+07. What is the difference between the Number of enrolments of both sexes in High income: nonOECD in 1977 and the Number of enrolments of both sexes in Antigua and Barbuda in 1978?
Provide a succinct answer. 1.52e+07. What is the difference between the Number of enrolments of both sexes of High income: nonOECD in 1977 and the Number of enrolments of both sexes of Turks and Caicos Islands in 1978?
Offer a terse response. 1.52e+07. What is the difference between the Number of enrolments of both sexes of Latin America(developing only) in 1977 and the Number of enrolments of both sexes of Antigua and Barbuda in 1978?
Provide a short and direct response. 4.29e+07. What is the difference between the Number of enrolments of both sexes of Latin America(developing only) in 1977 and the Number of enrolments of both sexes of Turks and Caicos Islands in 1978?
Offer a terse response. 4.29e+07. What is the difference between the Number of enrolments of both sexes of Antigua and Barbuda in 1977 and the Number of enrolments of both sexes of Turks and Caicos Islands in 1978?
Provide a succinct answer. 9220. What is the difference between the Number of enrolments of both sexes of High income: nonOECD in 1977 and the Number of enrolments of both sexes of Latin America(developing only) in 2000?
Your response must be concise. -4.40e+07. What is the difference between the Number of enrolments of both sexes of High income: nonOECD in 1977 and the Number of enrolments of both sexes of Antigua and Barbuda in 2000?
Offer a terse response. 1.52e+07. What is the difference between the Number of enrolments of both sexes of High income: nonOECD in 1977 and the Number of enrolments of both sexes of Turks and Caicos Islands in 2000?
Offer a terse response. 1.52e+07. What is the difference between the Number of enrolments of both sexes of Latin America(developing only) in 1977 and the Number of enrolments of both sexes of Antigua and Barbuda in 2000?
Provide a succinct answer. 4.28e+07. What is the difference between the Number of enrolments of both sexes in Latin America(developing only) in 1977 and the Number of enrolments of both sexes in Turks and Caicos Islands in 2000?
Keep it short and to the point. 4.29e+07. What is the difference between the Number of enrolments of both sexes in Antigua and Barbuda in 1977 and the Number of enrolments of both sexes in Turks and Caicos Islands in 2000?
Your answer should be very brief. 8894. What is the difference between the Number of enrolments of both sexes in High income: nonOECD in 1977 and the Number of enrolments of both sexes in Latin America(developing only) in 2009?
Make the answer very short. -4.17e+07. What is the difference between the Number of enrolments of both sexes in High income: nonOECD in 1977 and the Number of enrolments of both sexes in Antigua and Barbuda in 2009?
Provide a succinct answer. 1.52e+07. What is the difference between the Number of enrolments of both sexes in High income: nonOECD in 1977 and the Number of enrolments of both sexes in Turks and Caicos Islands in 2009?
Offer a terse response. 1.52e+07. What is the difference between the Number of enrolments of both sexes in Latin America(developing only) in 1977 and the Number of enrolments of both sexes in Antigua and Barbuda in 2009?
Offer a terse response. 4.29e+07. What is the difference between the Number of enrolments of both sexes of Latin America(developing only) in 1977 and the Number of enrolments of both sexes of Turks and Caicos Islands in 2009?
Keep it short and to the point. 4.29e+07. What is the difference between the Number of enrolments of both sexes of Antigua and Barbuda in 1977 and the Number of enrolments of both sexes of Turks and Caicos Islands in 2009?
Ensure brevity in your answer.  8021. What is the difference between the Number of enrolments of both sexes in High income: nonOECD in 1978 and the Number of enrolments of both sexes in Latin America(developing only) in 2000?
Your response must be concise. -4.38e+07. What is the difference between the Number of enrolments of both sexes in High income: nonOECD in 1978 and the Number of enrolments of both sexes in Antigua and Barbuda in 2000?
Offer a terse response. 1.54e+07. What is the difference between the Number of enrolments of both sexes of High income: nonOECD in 1978 and the Number of enrolments of both sexes of Turks and Caicos Islands in 2000?
Keep it short and to the point. 1.54e+07. What is the difference between the Number of enrolments of both sexes of Latin America(developing only) in 1978 and the Number of enrolments of both sexes of Antigua and Barbuda in 2000?
Keep it short and to the point. 4.42e+07. What is the difference between the Number of enrolments of both sexes in Latin America(developing only) in 1978 and the Number of enrolments of both sexes in Turks and Caicos Islands in 2000?
Make the answer very short. 4.42e+07. What is the difference between the Number of enrolments of both sexes of Antigua and Barbuda in 1978 and the Number of enrolments of both sexes of Turks and Caicos Islands in 2000?
Your answer should be very brief. 8141. What is the difference between the Number of enrolments of both sexes in High income: nonOECD in 1978 and the Number of enrolments of both sexes in Latin America(developing only) in 2009?
Offer a very short reply. -4.15e+07. What is the difference between the Number of enrolments of both sexes in High income: nonOECD in 1978 and the Number of enrolments of both sexes in Antigua and Barbuda in 2009?
Your response must be concise. 1.54e+07. What is the difference between the Number of enrolments of both sexes of High income: nonOECD in 1978 and the Number of enrolments of both sexes of Turks and Caicos Islands in 2009?
Offer a very short reply. 1.54e+07. What is the difference between the Number of enrolments of both sexes of Latin America(developing only) in 1978 and the Number of enrolments of both sexes of Antigua and Barbuda in 2009?
Your answer should be compact. 4.42e+07. What is the difference between the Number of enrolments of both sexes of Latin America(developing only) in 1978 and the Number of enrolments of both sexes of Turks and Caicos Islands in 2009?
Your response must be concise. 4.42e+07. What is the difference between the Number of enrolments of both sexes of Antigua and Barbuda in 1978 and the Number of enrolments of both sexes of Turks and Caicos Islands in 2009?
Provide a succinct answer. 7268. What is the difference between the Number of enrolments of both sexes in High income: nonOECD in 2000 and the Number of enrolments of both sexes in Latin America(developing only) in 2009?
Provide a succinct answer. -3.66e+07. What is the difference between the Number of enrolments of both sexes of High income: nonOECD in 2000 and the Number of enrolments of both sexes of Antigua and Barbuda in 2009?
Offer a terse response. 2.03e+07. What is the difference between the Number of enrolments of both sexes in High income: nonOECD in 2000 and the Number of enrolments of both sexes in Turks and Caicos Islands in 2009?
Provide a succinct answer. 2.03e+07. What is the difference between the Number of enrolments of both sexes in Latin America(developing only) in 2000 and the Number of enrolments of both sexes in Antigua and Barbuda in 2009?
Your response must be concise. 5.92e+07. What is the difference between the Number of enrolments of both sexes of Latin America(developing only) in 2000 and the Number of enrolments of both sexes of Turks and Caicos Islands in 2009?
Ensure brevity in your answer.  5.92e+07. What is the difference between the Number of enrolments of both sexes in Antigua and Barbuda in 2000 and the Number of enrolments of both sexes in Turks and Caicos Islands in 2009?
Your response must be concise. 1.01e+04. What is the average Number of enrolments of both sexes of High income: nonOECD per year?
Provide a succinct answer. 1.66e+07. What is the average Number of enrolments of both sexes of Latin America(developing only) per year?
Provide a succinct answer. 4.54e+07. What is the average Number of enrolments of both sexes in Antigua and Barbuda per year?
Ensure brevity in your answer.  1.13e+04. What is the average Number of enrolments of both sexes in Turks and Caicos Islands per year?
Make the answer very short. 1906.25. In the year 1972, what is the difference between the Number of enrolments of both sexes of High income: nonOECD and Number of enrolments of both sexes of Latin America(developing only)?
Your answer should be compact. -2.15e+07. In the year 1972, what is the difference between the Number of enrolments of both sexes of High income: nonOECD and Number of enrolments of both sexes of Antigua and Barbuda?
Keep it short and to the point. 1.62e+07. In the year 1972, what is the difference between the Number of enrolments of both sexes of High income: nonOECD and Number of enrolments of both sexes of Turks and Caicos Islands?
Give a very brief answer. 1.62e+07. In the year 1972, what is the difference between the Number of enrolments of both sexes in Latin America(developing only) and Number of enrolments of both sexes in Antigua and Barbuda?
Give a very brief answer. 3.76e+07. In the year 1972, what is the difference between the Number of enrolments of both sexes of Latin America(developing only) and Number of enrolments of both sexes of Turks and Caicos Islands?
Offer a terse response. 3.76e+07. In the year 1972, what is the difference between the Number of enrolments of both sexes in Antigua and Barbuda and Number of enrolments of both sexes in Turks and Caicos Islands?
Your answer should be very brief. 1.01e+04. In the year 1974, what is the difference between the Number of enrolments of both sexes of High income: nonOECD and Number of enrolments of both sexes of Latin America(developing only)?
Your answer should be very brief. -2.46e+07. In the year 1974, what is the difference between the Number of enrolments of both sexes in High income: nonOECD and Number of enrolments of both sexes in Antigua and Barbuda?
Your answer should be compact. 1.55e+07. In the year 1974, what is the difference between the Number of enrolments of both sexes of High income: nonOECD and Number of enrolments of both sexes of Turks and Caicos Islands?
Offer a very short reply. 1.55e+07. In the year 1974, what is the difference between the Number of enrolments of both sexes in Latin America(developing only) and Number of enrolments of both sexes in Antigua and Barbuda?
Your answer should be very brief. 4.01e+07. In the year 1974, what is the difference between the Number of enrolments of both sexes of Latin America(developing only) and Number of enrolments of both sexes of Turks and Caicos Islands?
Ensure brevity in your answer.  4.01e+07. In the year 1974, what is the difference between the Number of enrolments of both sexes in Antigua and Barbuda and Number of enrolments of both sexes in Turks and Caicos Islands?
Give a very brief answer. 9548. In the year 1975, what is the difference between the Number of enrolments of both sexes in High income: nonOECD and Number of enrolments of both sexes in Latin America(developing only)?
Make the answer very short. -2.54e+07. In the year 1975, what is the difference between the Number of enrolments of both sexes of High income: nonOECD and Number of enrolments of both sexes of Antigua and Barbuda?
Give a very brief answer. 1.52e+07. In the year 1975, what is the difference between the Number of enrolments of both sexes of High income: nonOECD and Number of enrolments of both sexes of Turks and Caicos Islands?
Your answer should be very brief. 1.52e+07. In the year 1975, what is the difference between the Number of enrolments of both sexes of Latin America(developing only) and Number of enrolments of both sexes of Antigua and Barbuda?
Offer a very short reply. 4.06e+07. In the year 1975, what is the difference between the Number of enrolments of both sexes in Latin America(developing only) and Number of enrolments of both sexes in Turks and Caicos Islands?
Give a very brief answer. 4.06e+07. In the year 1975, what is the difference between the Number of enrolments of both sexes of Antigua and Barbuda and Number of enrolments of both sexes of Turks and Caicos Islands?
Offer a terse response. 9313. In the year 1976, what is the difference between the Number of enrolments of both sexes of High income: nonOECD and Number of enrolments of both sexes of Latin America(developing only)?
Keep it short and to the point. -2.61e+07. In the year 1976, what is the difference between the Number of enrolments of both sexes of High income: nonOECD and Number of enrolments of both sexes of Antigua and Barbuda?
Offer a very short reply. 1.51e+07. In the year 1976, what is the difference between the Number of enrolments of both sexes of High income: nonOECD and Number of enrolments of both sexes of Turks and Caicos Islands?
Your answer should be very brief. 1.51e+07. In the year 1976, what is the difference between the Number of enrolments of both sexes of Latin America(developing only) and Number of enrolments of both sexes of Antigua and Barbuda?
Make the answer very short. 4.12e+07. In the year 1976, what is the difference between the Number of enrolments of both sexes in Latin America(developing only) and Number of enrolments of both sexes in Turks and Caicos Islands?
Give a very brief answer. 4.12e+07. In the year 1976, what is the difference between the Number of enrolments of both sexes in Antigua and Barbuda and Number of enrolments of both sexes in Turks and Caicos Islands?
Make the answer very short. 9576. In the year 1977, what is the difference between the Number of enrolments of both sexes in High income: nonOECD and Number of enrolments of both sexes in Latin America(developing only)?
Provide a succinct answer. -2.76e+07. In the year 1977, what is the difference between the Number of enrolments of both sexes of High income: nonOECD and Number of enrolments of both sexes of Antigua and Barbuda?
Keep it short and to the point. 1.52e+07. In the year 1977, what is the difference between the Number of enrolments of both sexes of High income: nonOECD and Number of enrolments of both sexes of Turks and Caicos Islands?
Give a very brief answer. 1.52e+07. In the year 1977, what is the difference between the Number of enrolments of both sexes of Latin America(developing only) and Number of enrolments of both sexes of Antigua and Barbuda?
Your answer should be very brief. 4.29e+07. In the year 1977, what is the difference between the Number of enrolments of both sexes in Latin America(developing only) and Number of enrolments of both sexes in Turks and Caicos Islands?
Give a very brief answer. 4.29e+07. In the year 1977, what is the difference between the Number of enrolments of both sexes in Antigua and Barbuda and Number of enrolments of both sexes in Turks and Caicos Islands?
Make the answer very short. 9112. In the year 1978, what is the difference between the Number of enrolments of both sexes in High income: nonOECD and Number of enrolments of both sexes in Latin America(developing only)?
Your response must be concise. -2.89e+07. In the year 1978, what is the difference between the Number of enrolments of both sexes in High income: nonOECD and Number of enrolments of both sexes in Antigua and Barbuda?
Make the answer very short. 1.54e+07. In the year 1978, what is the difference between the Number of enrolments of both sexes of High income: nonOECD and Number of enrolments of both sexes of Turks and Caicos Islands?
Provide a succinct answer. 1.54e+07. In the year 1978, what is the difference between the Number of enrolments of both sexes of Latin America(developing only) and Number of enrolments of both sexes of Antigua and Barbuda?
Provide a short and direct response. 4.42e+07. In the year 1978, what is the difference between the Number of enrolments of both sexes in Latin America(developing only) and Number of enrolments of both sexes in Turks and Caicos Islands?
Provide a succinct answer. 4.42e+07. In the year 1978, what is the difference between the Number of enrolments of both sexes in Antigua and Barbuda and Number of enrolments of both sexes in Turks and Caicos Islands?
Make the answer very short. 8467. In the year 2000, what is the difference between the Number of enrolments of both sexes of High income: nonOECD and Number of enrolments of both sexes of Latin America(developing only)?
Provide a short and direct response. -3.89e+07. In the year 2000, what is the difference between the Number of enrolments of both sexes of High income: nonOECD and Number of enrolments of both sexes of Antigua and Barbuda?
Offer a terse response. 2.03e+07. In the year 2000, what is the difference between the Number of enrolments of both sexes of High income: nonOECD and Number of enrolments of both sexes of Turks and Caicos Islands?
Make the answer very short. 2.03e+07. In the year 2000, what is the difference between the Number of enrolments of both sexes in Latin America(developing only) and Number of enrolments of both sexes in Antigua and Barbuda?
Keep it short and to the point. 5.92e+07. In the year 2000, what is the difference between the Number of enrolments of both sexes of Latin America(developing only) and Number of enrolments of both sexes of Turks and Caicos Islands?
Ensure brevity in your answer.  5.92e+07. In the year 2000, what is the difference between the Number of enrolments of both sexes of Antigua and Barbuda and Number of enrolments of both sexes of Turks and Caicos Islands?
Your response must be concise. 1.10e+04. In the year 2009, what is the difference between the Number of enrolments of both sexes in High income: nonOECD and Number of enrolments of both sexes in Latin America(developing only)?
Your response must be concise. -3.72e+07. In the year 2009, what is the difference between the Number of enrolments of both sexes in High income: nonOECD and Number of enrolments of both sexes in Antigua and Barbuda?
Provide a succinct answer. 1.96e+07. In the year 2009, what is the difference between the Number of enrolments of both sexes of High income: nonOECD and Number of enrolments of both sexes of Turks and Caicos Islands?
Ensure brevity in your answer.  1.97e+07. In the year 2009, what is the difference between the Number of enrolments of both sexes in Latin America(developing only) and Number of enrolments of both sexes in Antigua and Barbuda?
Offer a very short reply. 5.69e+07. In the year 2009, what is the difference between the Number of enrolments of both sexes in Latin America(developing only) and Number of enrolments of both sexes in Turks and Caicos Islands?
Give a very brief answer. 5.69e+07. In the year 2009, what is the difference between the Number of enrolments of both sexes of Antigua and Barbuda and Number of enrolments of both sexes of Turks and Caicos Islands?
Provide a short and direct response. 8385. What is the ratio of the Number of enrolments of both sexes in High income: nonOECD in 1972 to that in 1974?
Provide a succinct answer. 1.04. What is the ratio of the Number of enrolments of both sexes in Latin America(developing only) in 1972 to that in 1974?
Your answer should be compact. 0.94. What is the ratio of the Number of enrolments of both sexes of Antigua and Barbuda in 1972 to that in 1974?
Ensure brevity in your answer.  1.06. What is the ratio of the Number of enrolments of both sexes of Turks and Caicos Islands in 1972 to that in 1974?
Your response must be concise. 1.07. What is the ratio of the Number of enrolments of both sexes in High income: nonOECD in 1972 to that in 1975?
Give a very brief answer. 1.06. What is the ratio of the Number of enrolments of both sexes of Latin America(developing only) in 1972 to that in 1975?
Offer a terse response. 0.93. What is the ratio of the Number of enrolments of both sexes of Antigua and Barbuda in 1972 to that in 1975?
Give a very brief answer. 1.08. What is the ratio of the Number of enrolments of both sexes in Turks and Caicos Islands in 1972 to that in 1975?
Your response must be concise. 1.1. What is the ratio of the Number of enrolments of both sexes of High income: nonOECD in 1972 to that in 1976?
Offer a terse response. 1.07. What is the ratio of the Number of enrolments of both sexes in Antigua and Barbuda in 1972 to that in 1976?
Offer a terse response. 1.05. What is the ratio of the Number of enrolments of both sexes of Turks and Caicos Islands in 1972 to that in 1976?
Ensure brevity in your answer.  1.02. What is the ratio of the Number of enrolments of both sexes in High income: nonOECD in 1972 to that in 1977?
Provide a short and direct response. 1.06. What is the ratio of the Number of enrolments of both sexes of Latin America(developing only) in 1972 to that in 1977?
Offer a terse response. 0.88. What is the ratio of the Number of enrolments of both sexes of Antigua and Barbuda in 1972 to that in 1977?
Provide a succinct answer. 1.09. What is the ratio of the Number of enrolments of both sexes in High income: nonOECD in 1972 to that in 1978?
Keep it short and to the point. 1.05. What is the ratio of the Number of enrolments of both sexes in Latin America(developing only) in 1972 to that in 1978?
Make the answer very short. 0.85. What is the ratio of the Number of enrolments of both sexes in Antigua and Barbuda in 1972 to that in 1978?
Make the answer very short. 1.17. What is the ratio of the Number of enrolments of both sexes in Turks and Caicos Islands in 1972 to that in 1978?
Your answer should be very brief. 1.06. What is the ratio of the Number of enrolments of both sexes in High income: nonOECD in 1972 to that in 2000?
Give a very brief answer. 0.8. What is the ratio of the Number of enrolments of both sexes in Latin America(developing only) in 1972 to that in 2000?
Ensure brevity in your answer.  0.64. What is the ratio of the Number of enrolments of both sexes of Antigua and Barbuda in 1972 to that in 2000?
Keep it short and to the point. 0.91. What is the ratio of the Number of enrolments of both sexes of Turks and Caicos Islands in 1972 to that in 2000?
Give a very brief answer. 0.89. What is the ratio of the Number of enrolments of both sexes in High income: nonOECD in 1972 to that in 2009?
Make the answer very short. 0.82. What is the ratio of the Number of enrolments of both sexes in Latin America(developing only) in 1972 to that in 2009?
Offer a very short reply. 0.66. What is the ratio of the Number of enrolments of both sexes of Antigua and Barbuda in 1972 to that in 2009?
Your answer should be very brief. 1.05. What is the ratio of the Number of enrolments of both sexes in Turks and Caicos Islands in 1972 to that in 2009?
Give a very brief answer. 0.62. What is the ratio of the Number of enrolments of both sexes in High income: nonOECD in 1974 to that in 1975?
Provide a succinct answer. 1.02. What is the ratio of the Number of enrolments of both sexes in Latin America(developing only) in 1974 to that in 1975?
Offer a very short reply. 0.99. What is the ratio of the Number of enrolments of both sexes of Antigua and Barbuda in 1974 to that in 1975?
Ensure brevity in your answer.  1.03. What is the ratio of the Number of enrolments of both sexes in Turks and Caicos Islands in 1974 to that in 1975?
Your response must be concise. 1.03. What is the ratio of the Number of enrolments of both sexes in High income: nonOECD in 1974 to that in 1976?
Provide a short and direct response. 1.02. What is the ratio of the Number of enrolments of both sexes of Latin America(developing only) in 1974 to that in 1976?
Make the answer very short. 0.97. What is the ratio of the Number of enrolments of both sexes in Turks and Caicos Islands in 1974 to that in 1976?
Your answer should be compact. 0.95. What is the ratio of the Number of enrolments of both sexes in High income: nonOECD in 1974 to that in 1977?
Provide a succinct answer. 1.02. What is the ratio of the Number of enrolments of both sexes in Latin America(developing only) in 1974 to that in 1977?
Offer a very short reply. 0.93. What is the ratio of the Number of enrolments of both sexes in Antigua and Barbuda in 1974 to that in 1977?
Offer a terse response. 1.03. What is the ratio of the Number of enrolments of both sexes of Turks and Caicos Islands in 1974 to that in 1977?
Your response must be concise. 0.93. What is the ratio of the Number of enrolments of both sexes of Latin America(developing only) in 1974 to that in 1978?
Your answer should be very brief. 0.91. What is the ratio of the Number of enrolments of both sexes in Antigua and Barbuda in 1974 to that in 1978?
Make the answer very short. 1.1. What is the ratio of the Number of enrolments of both sexes of Turks and Caicos Islands in 1974 to that in 1978?
Provide a succinct answer. 0.99. What is the ratio of the Number of enrolments of both sexes of High income: nonOECD in 1974 to that in 2000?
Provide a succinct answer. 0.77. What is the ratio of the Number of enrolments of both sexes in Latin America(developing only) in 1974 to that in 2000?
Your answer should be very brief. 0.68. What is the ratio of the Number of enrolments of both sexes of Antigua and Barbuda in 1974 to that in 2000?
Offer a very short reply. 0.86. What is the ratio of the Number of enrolments of both sexes of Turks and Caicos Islands in 1974 to that in 2000?
Your answer should be compact. 0.83. What is the ratio of the Number of enrolments of both sexes of High income: nonOECD in 1974 to that in 2009?
Ensure brevity in your answer.  0.79. What is the ratio of the Number of enrolments of both sexes in Latin America(developing only) in 1974 to that in 2009?
Offer a terse response. 0.7. What is the ratio of the Number of enrolments of both sexes in Antigua and Barbuda in 1974 to that in 2009?
Offer a terse response. 0.99. What is the ratio of the Number of enrolments of both sexes of Turks and Caicos Islands in 1974 to that in 2009?
Provide a succinct answer. 0.58. What is the ratio of the Number of enrolments of both sexes of High income: nonOECD in 1975 to that in 1976?
Your response must be concise. 1.01. What is the ratio of the Number of enrolments of both sexes of Latin America(developing only) in 1975 to that in 1976?
Ensure brevity in your answer.  0.99. What is the ratio of the Number of enrolments of both sexes in Antigua and Barbuda in 1975 to that in 1976?
Provide a succinct answer. 0.96. What is the ratio of the Number of enrolments of both sexes in Turks and Caicos Islands in 1975 to that in 1976?
Offer a very short reply. 0.92. What is the ratio of the Number of enrolments of both sexes in Latin America(developing only) in 1975 to that in 1977?
Ensure brevity in your answer.  0.95. What is the ratio of the Number of enrolments of both sexes in Turks and Caicos Islands in 1975 to that in 1977?
Offer a terse response. 0.9. What is the ratio of the Number of enrolments of both sexes in Latin America(developing only) in 1975 to that in 1978?
Your answer should be compact. 0.92. What is the ratio of the Number of enrolments of both sexes in Antigua and Barbuda in 1975 to that in 1978?
Provide a succinct answer. 1.08. What is the ratio of the Number of enrolments of both sexes of High income: nonOECD in 1975 to that in 2000?
Your response must be concise. 0.75. What is the ratio of the Number of enrolments of both sexes of Latin America(developing only) in 1975 to that in 2000?
Provide a short and direct response. 0.69. What is the ratio of the Number of enrolments of both sexes in Antigua and Barbuda in 1975 to that in 2000?
Offer a terse response. 0.84. What is the ratio of the Number of enrolments of both sexes of Turks and Caicos Islands in 1975 to that in 2000?
Offer a terse response. 0.81. What is the ratio of the Number of enrolments of both sexes of High income: nonOECD in 1975 to that in 2009?
Offer a very short reply. 0.78. What is the ratio of the Number of enrolments of both sexes in Latin America(developing only) in 1975 to that in 2009?
Keep it short and to the point. 0.71. What is the ratio of the Number of enrolments of both sexes of Antigua and Barbuda in 1975 to that in 2009?
Your answer should be compact. 0.97. What is the ratio of the Number of enrolments of both sexes in Turks and Caicos Islands in 1975 to that in 2009?
Provide a short and direct response. 0.56. What is the ratio of the Number of enrolments of both sexes of Antigua and Barbuda in 1976 to that in 1977?
Offer a terse response. 1.04. What is the ratio of the Number of enrolments of both sexes in Turks and Caicos Islands in 1976 to that in 1977?
Make the answer very short. 0.98. What is the ratio of the Number of enrolments of both sexes of High income: nonOECD in 1976 to that in 1978?
Provide a succinct answer. 0.98. What is the ratio of the Number of enrolments of both sexes of Latin America(developing only) in 1976 to that in 1978?
Ensure brevity in your answer.  0.93. What is the ratio of the Number of enrolments of both sexes in Antigua and Barbuda in 1976 to that in 1978?
Offer a terse response. 1.12. What is the ratio of the Number of enrolments of both sexes of Turks and Caicos Islands in 1976 to that in 1978?
Your response must be concise. 1.04. What is the ratio of the Number of enrolments of both sexes of High income: nonOECD in 1976 to that in 2000?
Provide a short and direct response. 0.75. What is the ratio of the Number of enrolments of both sexes of Latin America(developing only) in 1976 to that in 2000?
Offer a terse response. 0.7. What is the ratio of the Number of enrolments of both sexes in Antigua and Barbuda in 1976 to that in 2000?
Offer a very short reply. 0.87. What is the ratio of the Number of enrolments of both sexes in Turks and Caicos Islands in 1976 to that in 2000?
Your answer should be very brief. 0.87. What is the ratio of the Number of enrolments of both sexes of High income: nonOECD in 1976 to that in 2009?
Provide a succinct answer. 0.77. What is the ratio of the Number of enrolments of both sexes in Latin America(developing only) in 1976 to that in 2009?
Provide a short and direct response. 0.72. What is the ratio of the Number of enrolments of both sexes of Antigua and Barbuda in 1976 to that in 2009?
Your response must be concise. 1.01. What is the ratio of the Number of enrolments of both sexes of Turks and Caicos Islands in 1976 to that in 2009?
Keep it short and to the point. 0.61. What is the ratio of the Number of enrolments of both sexes in High income: nonOECD in 1977 to that in 1978?
Provide a succinct answer. 0.99. What is the ratio of the Number of enrolments of both sexes in Latin America(developing only) in 1977 to that in 1978?
Give a very brief answer. 0.97. What is the ratio of the Number of enrolments of both sexes of Antigua and Barbuda in 1977 to that in 1978?
Offer a terse response. 1.07. What is the ratio of the Number of enrolments of both sexes of Turks and Caicos Islands in 1977 to that in 1978?
Ensure brevity in your answer.  1.06. What is the ratio of the Number of enrolments of both sexes in High income: nonOECD in 1977 to that in 2000?
Keep it short and to the point. 0.75. What is the ratio of the Number of enrolments of both sexes of Latin America(developing only) in 1977 to that in 2000?
Your answer should be very brief. 0.72. What is the ratio of the Number of enrolments of both sexes in Antigua and Barbuda in 1977 to that in 2000?
Your response must be concise. 0.84. What is the ratio of the Number of enrolments of both sexes in Turks and Caicos Islands in 1977 to that in 2000?
Provide a short and direct response. 0.89. What is the ratio of the Number of enrolments of both sexes of High income: nonOECD in 1977 to that in 2009?
Provide a short and direct response. 0.77. What is the ratio of the Number of enrolments of both sexes in Latin America(developing only) in 1977 to that in 2009?
Provide a short and direct response. 0.75. What is the ratio of the Number of enrolments of both sexes of Turks and Caicos Islands in 1977 to that in 2009?
Give a very brief answer. 0.62. What is the ratio of the Number of enrolments of both sexes in High income: nonOECD in 1978 to that in 2000?
Give a very brief answer. 0.76. What is the ratio of the Number of enrolments of both sexes in Latin America(developing only) in 1978 to that in 2000?
Provide a short and direct response. 0.75. What is the ratio of the Number of enrolments of both sexes of Antigua and Barbuda in 1978 to that in 2000?
Ensure brevity in your answer.  0.78. What is the ratio of the Number of enrolments of both sexes of Turks and Caicos Islands in 1978 to that in 2000?
Give a very brief answer. 0.84. What is the ratio of the Number of enrolments of both sexes of High income: nonOECD in 1978 to that in 2009?
Provide a short and direct response. 0.78. What is the ratio of the Number of enrolments of both sexes in Latin America(developing only) in 1978 to that in 2009?
Keep it short and to the point. 0.78. What is the ratio of the Number of enrolments of both sexes of Antigua and Barbuda in 1978 to that in 2009?
Give a very brief answer. 0.9. What is the ratio of the Number of enrolments of both sexes in Turks and Caicos Islands in 1978 to that in 2009?
Your answer should be very brief. 0.59. What is the ratio of the Number of enrolments of both sexes of High income: nonOECD in 2000 to that in 2009?
Your response must be concise. 1.03. What is the ratio of the Number of enrolments of both sexes of Latin America(developing only) in 2000 to that in 2009?
Offer a very short reply. 1.04. What is the ratio of the Number of enrolments of both sexes of Antigua and Barbuda in 2000 to that in 2009?
Ensure brevity in your answer.  1.16. What is the ratio of the Number of enrolments of both sexes of Turks and Caicos Islands in 2000 to that in 2009?
Offer a very short reply. 0.7. What is the difference between the highest and the second highest Number of enrolments of both sexes of High income: nonOECD?
Provide a short and direct response. 6.07e+05. What is the difference between the highest and the second highest Number of enrolments of both sexes of Latin America(developing only)?
Your response must be concise. 2.30e+06. What is the difference between the highest and the second highest Number of enrolments of both sexes in Antigua and Barbuda?
Give a very brief answer. 1173. What is the difference between the highest and the second highest Number of enrolments of both sexes in Turks and Caicos Islands?
Your response must be concise. 873. What is the difference between the highest and the lowest Number of enrolments of both sexes in High income: nonOECD?
Offer a very short reply. 5.11e+06. What is the difference between the highest and the lowest Number of enrolments of both sexes of Latin America(developing only)?
Ensure brevity in your answer.  2.16e+07. What is the difference between the highest and the lowest Number of enrolments of both sexes in Antigua and Barbuda?
Ensure brevity in your answer.  2866. What is the difference between the highest and the lowest Number of enrolments of both sexes in Turks and Caicos Islands?
Your response must be concise. 1265. 